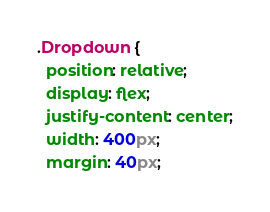Convert code to text. <code><loc_0><loc_0><loc_500><loc_500><_CSS_>.Dropdown {
  position: relative;
  display: flex;
  justify-content: center;
  width: 400px;
  margin: 40px;</code> 